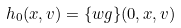<formula> <loc_0><loc_0><loc_500><loc_500>h _ { 0 } ( x , v ) = \{ w g \} ( 0 , x , v )</formula> 